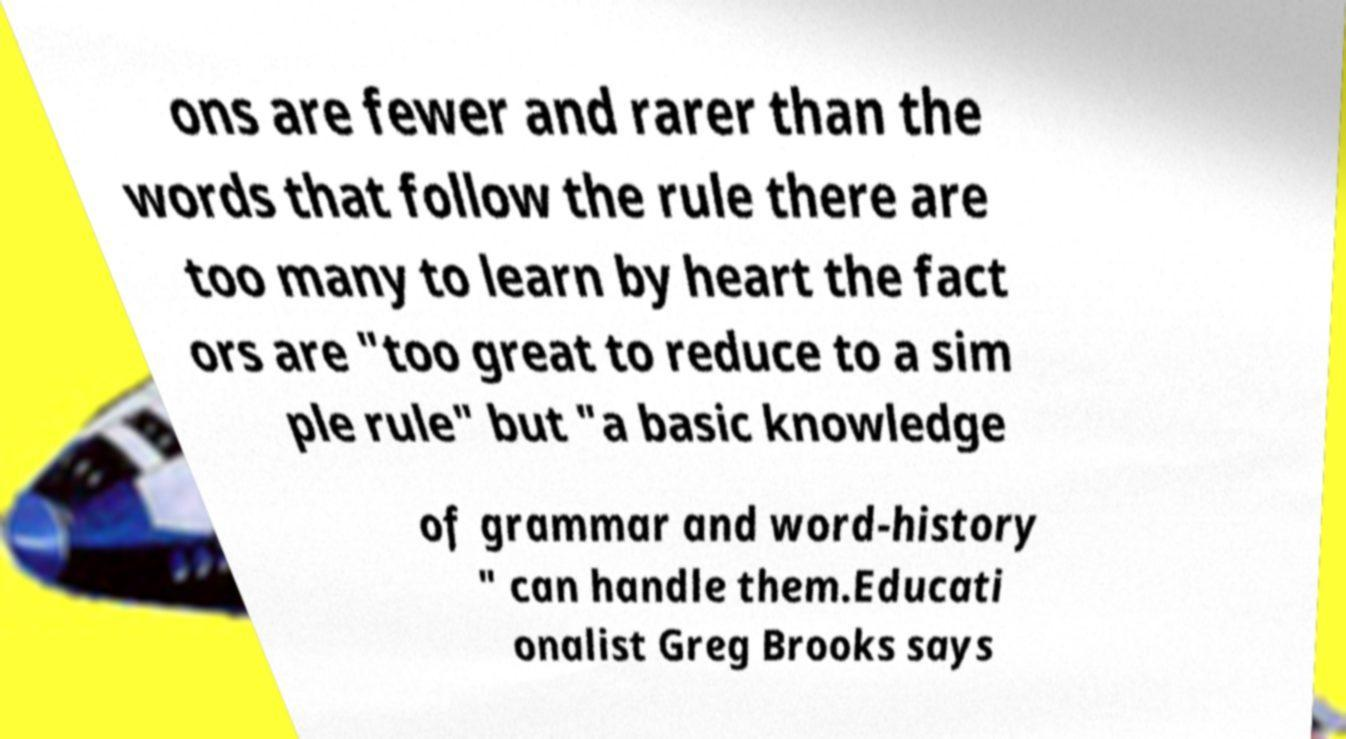What messages or text are displayed in this image? I need them in a readable, typed format. ons are fewer and rarer than the words that follow the rule there are too many to learn by heart the fact ors are "too great to reduce to a sim ple rule" but "a basic knowledge of grammar and word-history " can handle them.Educati onalist Greg Brooks says 